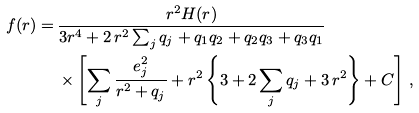<formula> <loc_0><loc_0><loc_500><loc_500>f ( r ) = \, & \frac { r ^ { 2 } H ( r ) } { 3 r ^ { 4 } + 2 \, r ^ { 2 } \sum _ { j } q _ { j } + q _ { 1 } q _ { 2 } + q _ { 2 } q _ { 3 } + q _ { 3 } q _ { 1 } } \\ & \times \left [ \sum _ { j } \frac { e _ { j } ^ { 2 } } { r ^ { 2 } + q _ { j } } + r ^ { 2 } \left \{ 3 + 2 \sum _ { j } q _ { j } + 3 \, r ^ { 2 } \right \} + C \right ] \, ,</formula> 